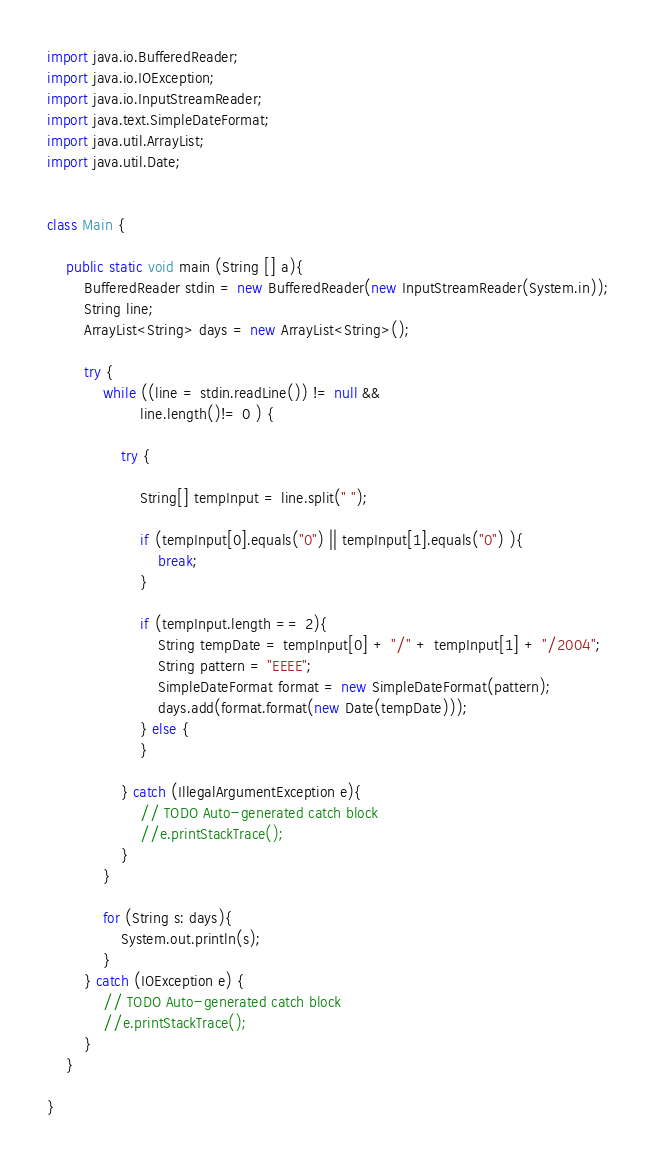<code> <loc_0><loc_0><loc_500><loc_500><_Java_>import java.io.BufferedReader;
import java.io.IOException;
import java.io.InputStreamReader;
import java.text.SimpleDateFormat;
import java.util.ArrayList;
import java.util.Date;


class Main {

	public static void main (String [] a){
		BufferedReader stdin = new BufferedReader(new InputStreamReader(System.in));
		String line;
		ArrayList<String> days = new ArrayList<String>();
		
		try {
			while ((line = stdin.readLine()) != null && 
					line.length()!= 0 ) {
				
				try {
					
					String[] tempInput = line.split(" ");
					
					if (tempInput[0].equals("0") || tempInput[1].equals("0") ){
						break;
					}
					
					if (tempInput.length == 2){
						String tempDate = tempInput[0] + "/" + tempInput[1] + "/2004";
						String pattern = "EEEE";
					    SimpleDateFormat format = new SimpleDateFormat(pattern);
				        days.add(format.format(new Date(tempDate)));
					} else {
					}
					
				} catch (IllegalArgumentException e){
					// TODO Auto-generated catch block
					//e.printStackTrace();
				}
			}
			
			for (String s: days){
				System.out.println(s);
			}
		} catch (IOException e) {
			// TODO Auto-generated catch block
			//e.printStackTrace();
		}
	}
	
}</code> 